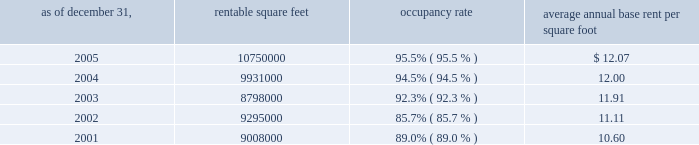Properties 33vornado realty trust supermarkets , home improvement stores , discount apparel stores and membership warehouse clubs .
Tenants typically offer basic consumer necessities such as food , health and beauty aids , moderately priced clothing , building materials and home improvement supplies , and compete primarily on the basis of price and location .
Regional malls : the green acres mall in long island , new york contains 1.6 million square feet , and is anchored by four major department stores : sears , j.c .
Penney , federated department stores , doing business as macy 2019s and macy 2019s men 2019s furniture gallery .
The complex also includes the plaza at green acres , a 175000 square foot strip shopping center which is anchored by wal-mart and national wholesale liquidators .
The company plans to renovate the interior and exterior of the mall and construct 100000 square feet of free-standing retail space and parking decks in the complex , subject to governmental approvals .
In addition , the company has entered into a ground lease with b.j . 2019s wholesale club who will construct its own free-standing store in the mall complex .
The expansion and renovation are expected to be completed in 2007 .
The monmouth mall in eatontown , new jersey , owned 50% ( 50 % ) by the company , contains 1.4 million square feet and is anchored by four department stores ; macy 2019s , lord & taylor , j.c .
Penney and boscovs , three of which own their stores aggregating 719000 square feet .
The joint venture plans to construct 80000 square feet of free-standing retail space in the mall complex , subject to governmental approvals .
The expansion is expected to be completed in 2007 .
The broadway mall in hicksville , long island , new york , contains 1.2 million square feet and is anchored by macy 2019s , ikea , multiplex cinema and target , which owns its store containing 141000 square feet .
The bergen mall in paramus , new jersey , as currently exists , contains 900000 square feet .
The company plans to demolish approximately 300000 square feet and construct approximately 580000 square feet of retail space , which will bring the total square footage of the mall to approximately 1360000 , including 180000 square feet to be built by target on land leased from the company .
As of december 31 , 2005 , the company has taken 480000 square feet out of service for redevelopment and leased 236000 square feet to century 21 and whole foods .
All of the foregoing is subject to governmental approvals .
The expansion and renovations , as planned , are expected to be completed in 2008 .
The montehiedra mall in san juan , puerto rico , contains 563000 square feet and is anchored by home depot , kmart , and marshalls .
The south hills mall in poughkeepsie , new york , contains 668000 square feet and is anchored by kmart and burlington coat factory .
The company plans to redevelop and retenant the mall , subject to governmental approvals .
The las catalinas mall in san juan , puerto rico , contains 495000 square feet and is anchored by kmart and sears , which owns its 140000 square foot store .
Occupancy and average annual base rent per square foot : at december 31 , 2005 , the aggregate occupancy rate for the 16169000 square feet of retail properties was 95.6% ( 95.6 % ) .
Strip shopping centers : average annual rentable base rent as of december 31 , square feet occupancy rate per square foot .

In rentable square , what was the change between 2005 and 2004? 
Computations: (10750000 - 9931000)
Answer: 819000.0. 